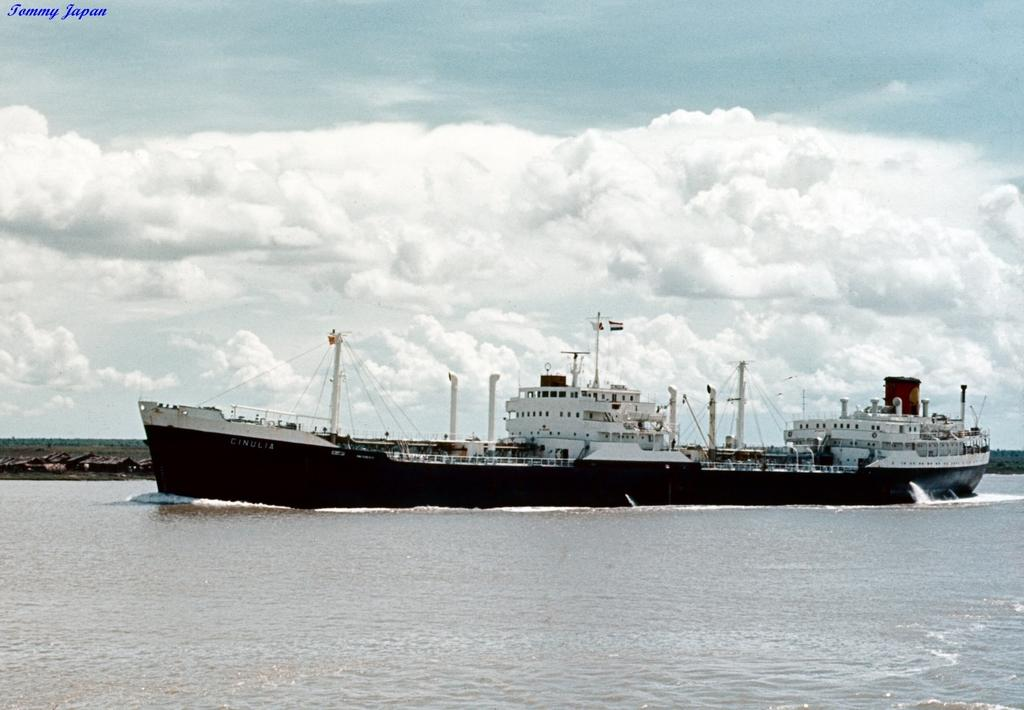What is the primary element in the image? There is water in the image. What can be seen floating on the water? There is a black-colored ship in the water. What else is visible in the image besides the water and ship? There are wires visible in the image. What can be seen in the background of the image? There are clouds and the sky visible in the background of the image. What type of drink can be seen being served from the mailbox in the image? There is no mailbox or drink present in the image. How many bears are visible in the image? There are no bears present in the image. 